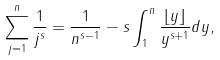<formula> <loc_0><loc_0><loc_500><loc_500>\sum _ { j = 1 } ^ { n } \frac { 1 } { j ^ { s } } = \frac { 1 } { n ^ { s - 1 } } - s \int _ { 1 } ^ { n } \frac { \lfloor { y } \rfloor } { y ^ { s + 1 } } d y ,</formula> 